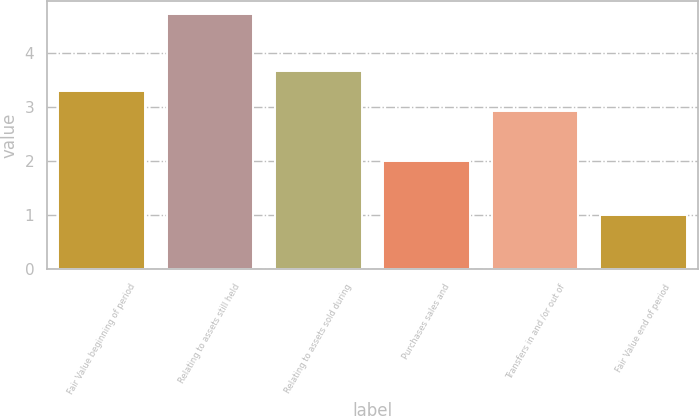Convert chart to OTSL. <chart><loc_0><loc_0><loc_500><loc_500><bar_chart><fcel>Fair Value beginning of period<fcel>Relating to assets still held<fcel>Relating to assets sold during<fcel>Purchases sales and<fcel>Transfers in and /or out of<fcel>Fair Value end of period<nl><fcel>3.31<fcel>4.74<fcel>3.68<fcel>2<fcel>2.94<fcel>1<nl></chart> 